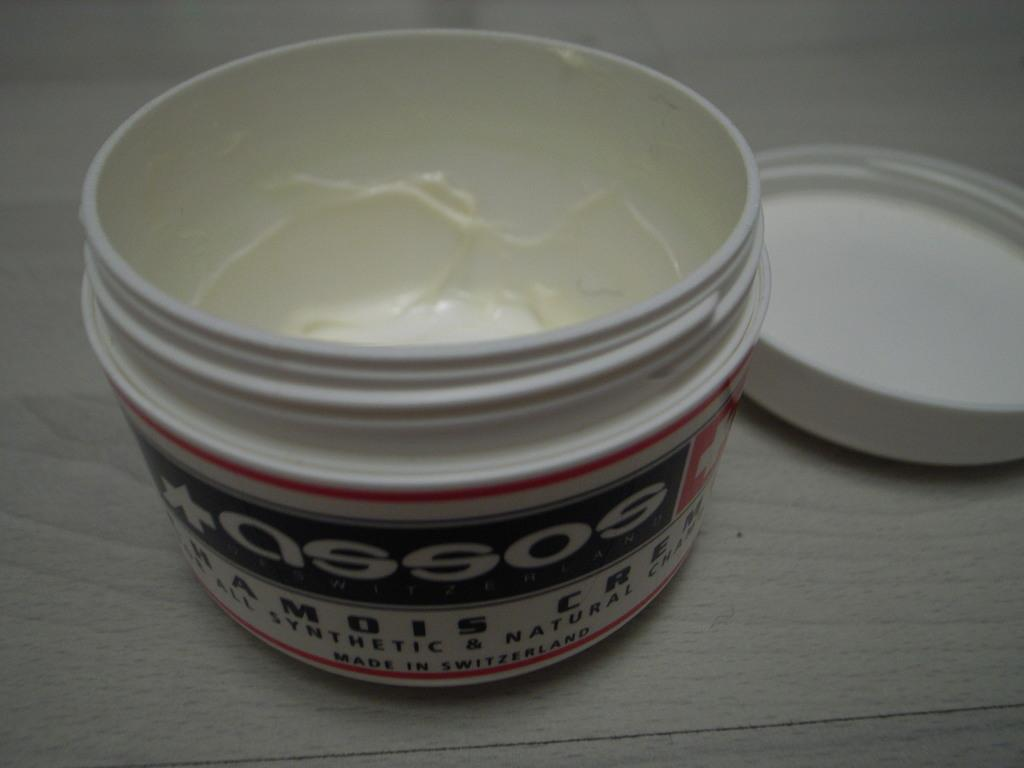<image>
Create a compact narrative representing the image presented. Assos cream that is all Synthetic & Natural, Made in Switzerland. 